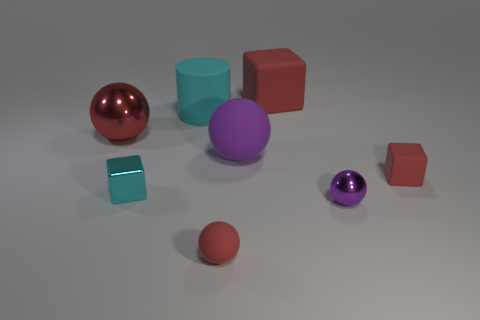Add 1 cyan cylinders. How many objects exist? 9 Subtract all cyan spheres. Subtract all gray cylinders. How many spheres are left? 4 Subtract all cubes. How many objects are left? 5 Subtract all large matte spheres. Subtract all cyan matte cylinders. How many objects are left? 6 Add 6 matte blocks. How many matte blocks are left? 8 Add 3 brown metal cylinders. How many brown metal cylinders exist? 3 Subtract 0 cyan balls. How many objects are left? 8 